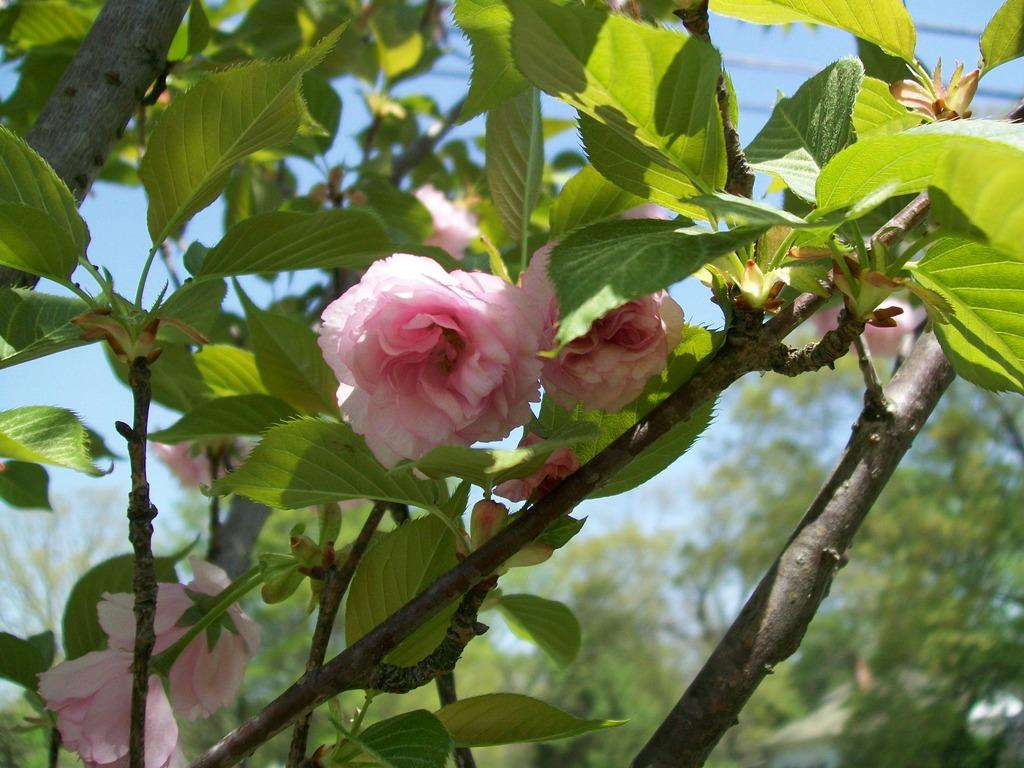What type of flora is present in the image? There are flowers in the image. What colors are the flowers? The flowers are in pink and white colors. What can be seen in the background of the image? There are trees in the background of the image. What is the color of the trees? The trees are green. What is visible above the trees in the image? The sky is blue. Can you measure the speed of the snail in the image? There is no snail present in the image, so it is not possible to measure its speed. 